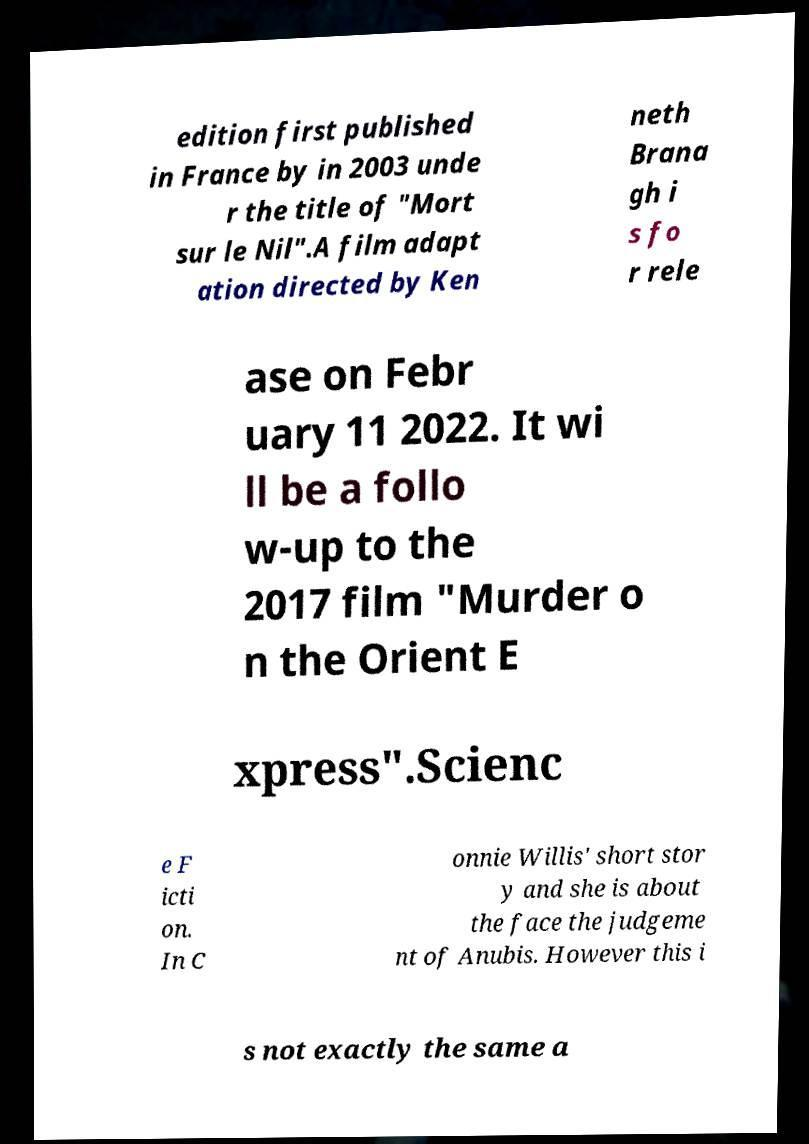I need the written content from this picture converted into text. Can you do that? edition first published in France by in 2003 unde r the title of "Mort sur le Nil".A film adapt ation directed by Ken neth Brana gh i s fo r rele ase on Febr uary 11 2022. It wi ll be a follo w-up to the 2017 film "Murder o n the Orient E xpress".Scienc e F icti on. In C onnie Willis' short stor y and she is about the face the judgeme nt of Anubis. However this i s not exactly the same a 